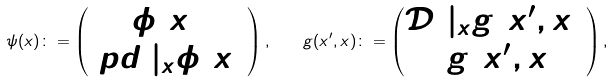Convert formula to latex. <formula><loc_0><loc_0><loc_500><loc_500>\psi ( x ) \colon = \begin{pmatrix} \phi ( x ) \\ \ p d _ { 0 } | _ { x } \phi ( x ) \end{pmatrix} , \quad g ( x ^ { \prime } , x ) \colon = \begin{pmatrix} \mathcal { D } _ { 0 } | _ { x } g ( x ^ { \prime } , x ) \\ 2 g ( x ^ { \prime } , x ) \end{pmatrix} ,</formula> 